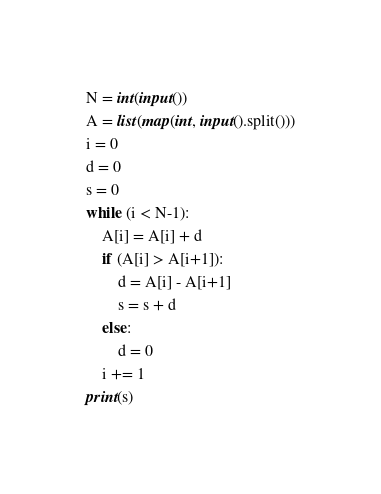<code> <loc_0><loc_0><loc_500><loc_500><_Python_>N = int(input())
A = list(map(int, input().split()))
i = 0
d = 0
s = 0
while (i < N-1):
    A[i] = A[i] + d
    if (A[i] > A[i+1]):
        d = A[i] - A[i+1]
        s = s + d
    else:
        d = 0
    i += 1
print(s)</code> 